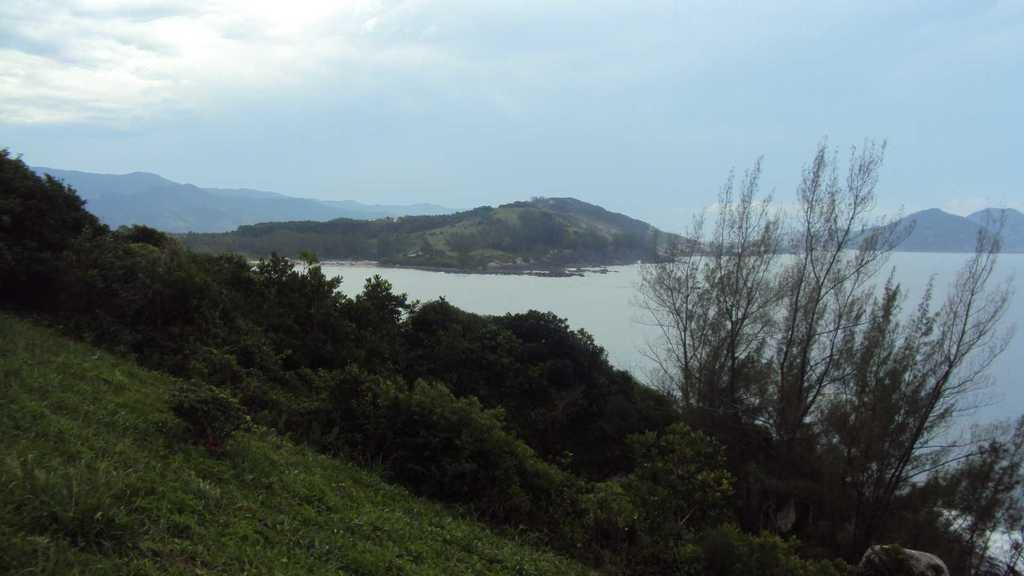What type of ground surface is visible in the image? There is grass on the ground in the image. Can you describe the plants in the image? There are plants in the image, from left to right. What type of landscape feature can be seen in the distance? There are mountains visible in the image. How would you describe the sky in the image? The sky is blue and cloudy in the image. What type of coil is visible in the image? There is no coil present in the image. Can you describe the lunar system in the image? There is no lunar system present in the image; it features grass, plants, mountains, and a blue, cloudy sky. 